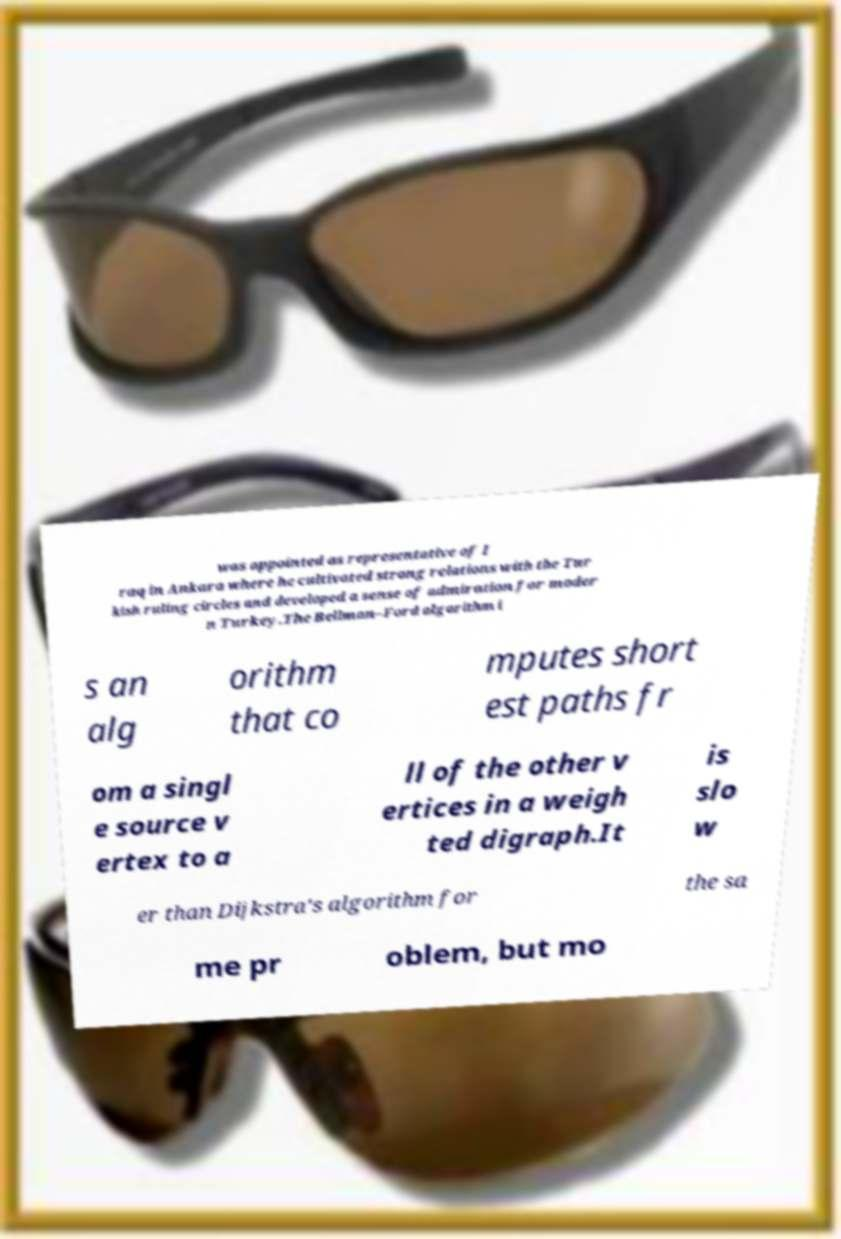Please read and relay the text visible in this image. What does it say? was appointed as representative of I raq in Ankara where he cultivated strong relations with the Tur kish ruling circles and developed a sense of admiration for moder n Turkey.The Bellman–Ford algorithm i s an alg orithm that co mputes short est paths fr om a singl e source v ertex to a ll of the other v ertices in a weigh ted digraph.It is slo w er than Dijkstra's algorithm for the sa me pr oblem, but mo 